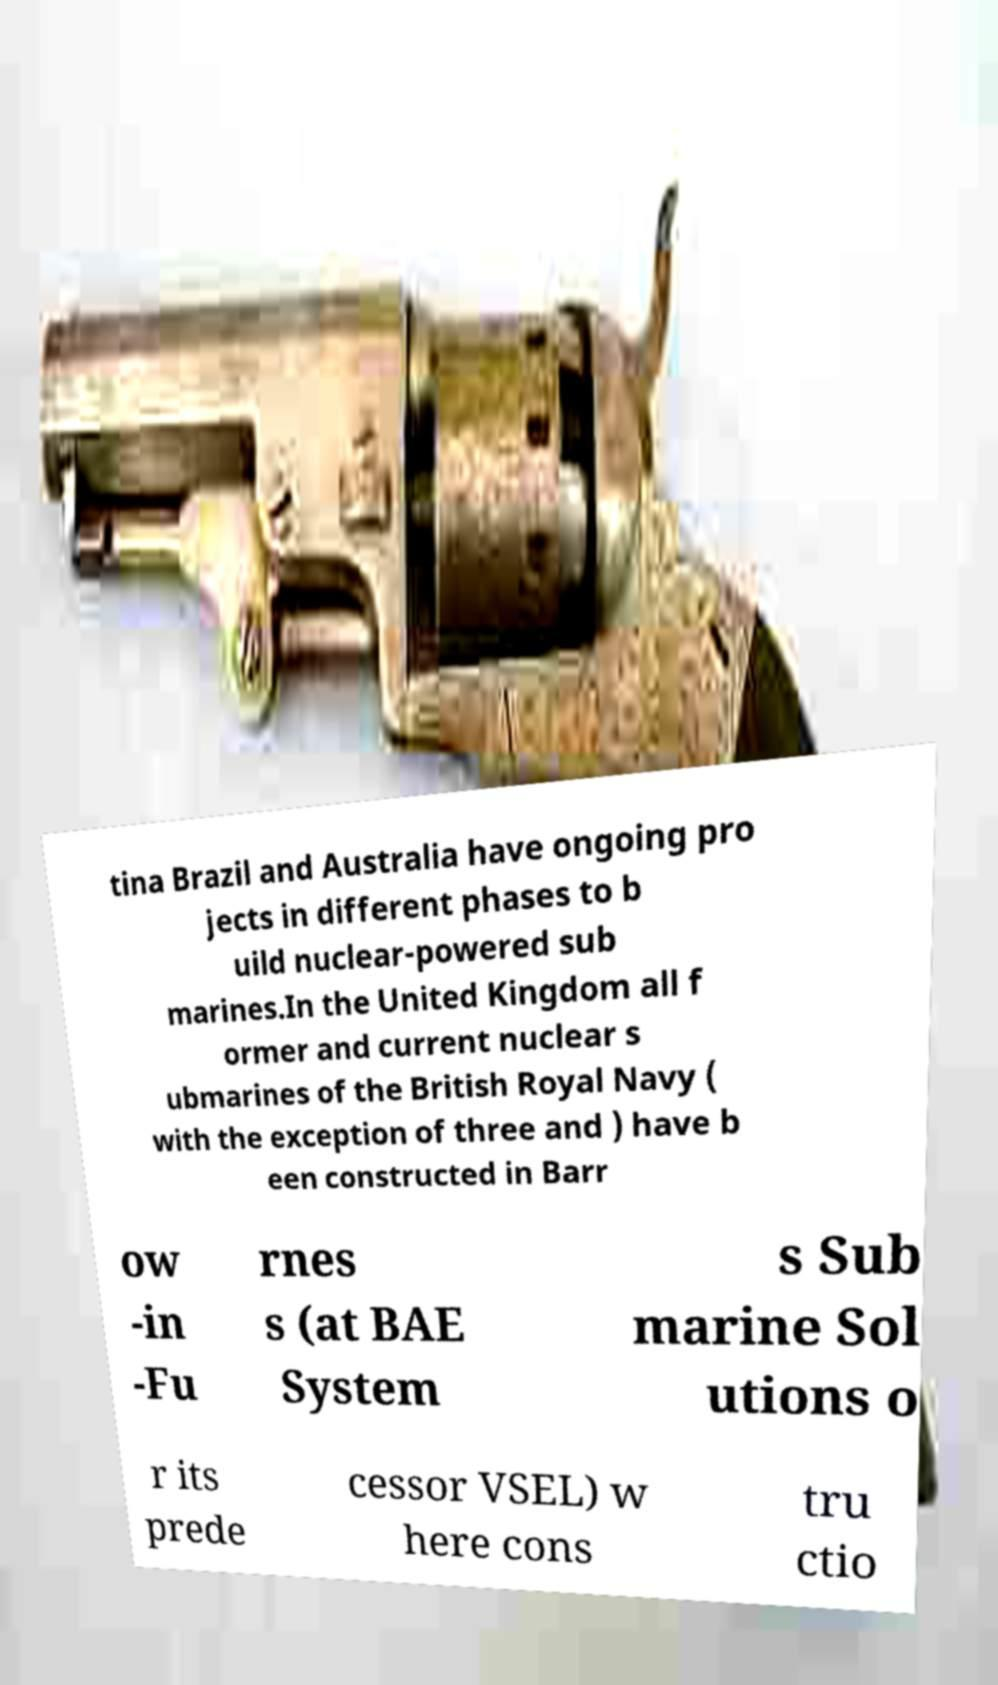Please read and relay the text visible in this image. What does it say? tina Brazil and Australia have ongoing pro jects in different phases to b uild nuclear-powered sub marines.In the United Kingdom all f ormer and current nuclear s ubmarines of the British Royal Navy ( with the exception of three and ) have b een constructed in Barr ow -in -Fu rnes s (at BAE System s Sub marine Sol utions o r its prede cessor VSEL) w here cons tru ctio 